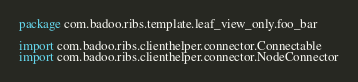<code> <loc_0><loc_0><loc_500><loc_500><_Kotlin_>package com.badoo.ribs.template.leaf_view_only.foo_bar

import com.badoo.ribs.clienthelper.connector.Connectable
import com.badoo.ribs.clienthelper.connector.NodeConnector</code> 